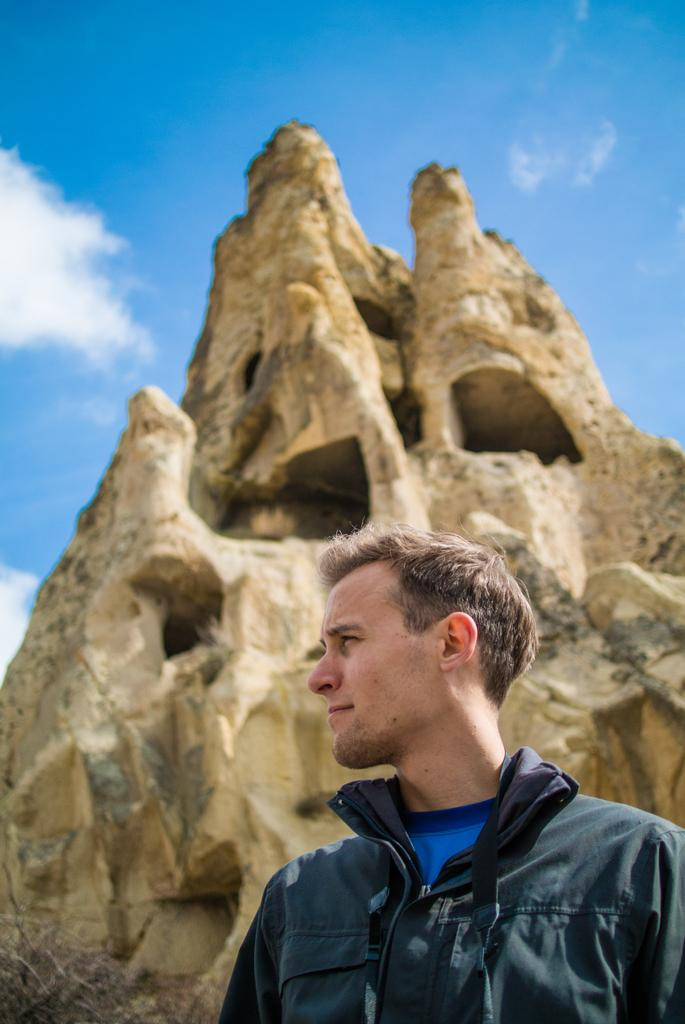Who is present in the image? There is a man in the image. What is the man standing in front of? The man is standing in front of a hill. What is the man wearing on his upper body? The man is wearing a black jacket and a blue t-shirt. What can be seen in the sky in the image? There are patches of cloud in the sky. What type of underwear is the man wearing in the image? There is no information about the man's underwear in the image, so it cannot be determined. 